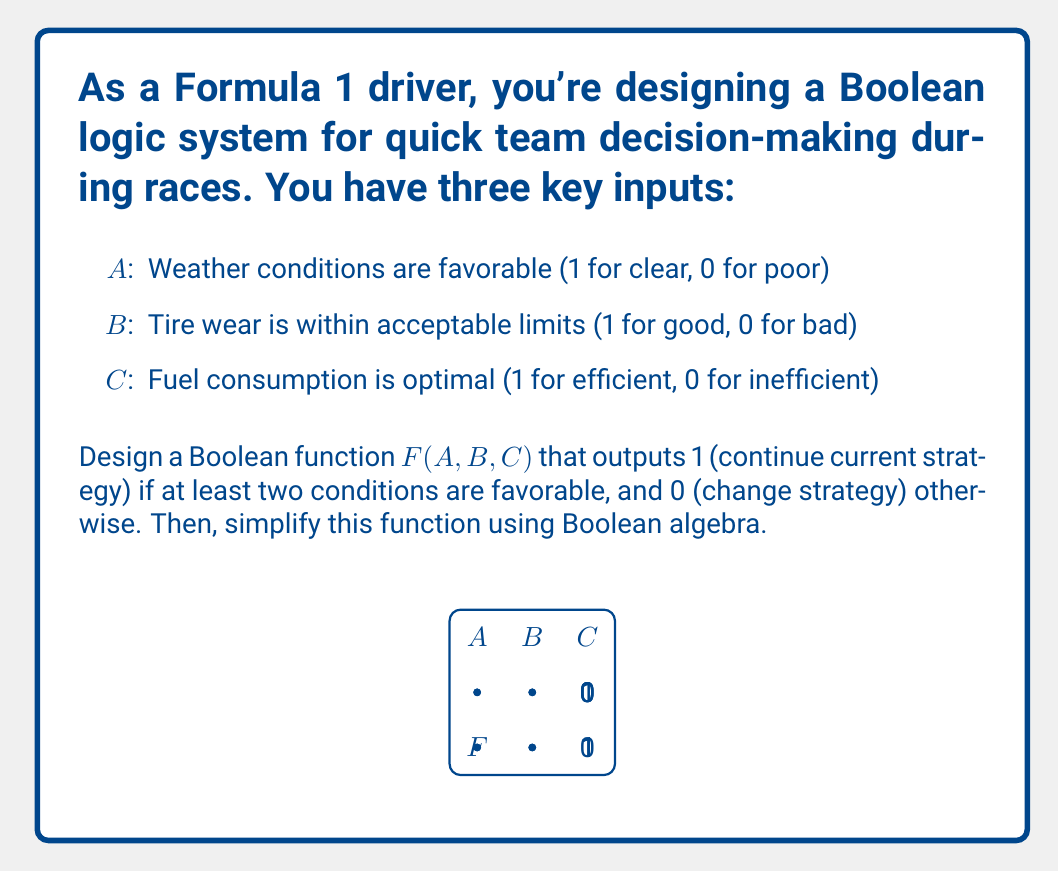Could you help me with this problem? Let's approach this step-by-step:

1) First, we need to create a function that outputs 1 when at least two inputs are 1. This can be expressed as:

   $F(A,B,C) = AB + AC + BC$

   This function will be 1 if any two (or all three) inputs are 1.

2) To simplify this function, we can use Boolean algebra laws. Let's start by applying the distributive law:

   $F(A,B,C) = AB + AC + BC$
             $= AB + (A+B)C$  (factoring out C)

3) Now, let's apply the absorption law $(X + XY = X)$:

   $F(A,B,C) = AB + (A+B)C$
             $= (A+C)(B+C)$  (This is a key step in simplification)

4) This simplified form $(A+C)(B+C)$ is known as the "consensus theorem" and is equivalent to our original function.

5) We can verify this by expanding:

   $(A+C)(B+C) = AB + AC + BC + C^2$
                $= AB + AC + BC + C$  (since $C^2 = C$ in Boolean algebra)
                $= AB + AC + BC$  (absorbing C into AC and BC)

Thus, our simplified Boolean function for the team decision-making process is $F(A,B,C) = (A+C)(B+C)$.
Answer: $F(A,B,C) = (A+C)(B+C)$ 